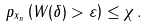<formula> <loc_0><loc_0><loc_500><loc_500>\ p _ { x _ { n } } \left ( W ( \delta ) > \varepsilon \right ) \leq \chi \, . \\</formula> 